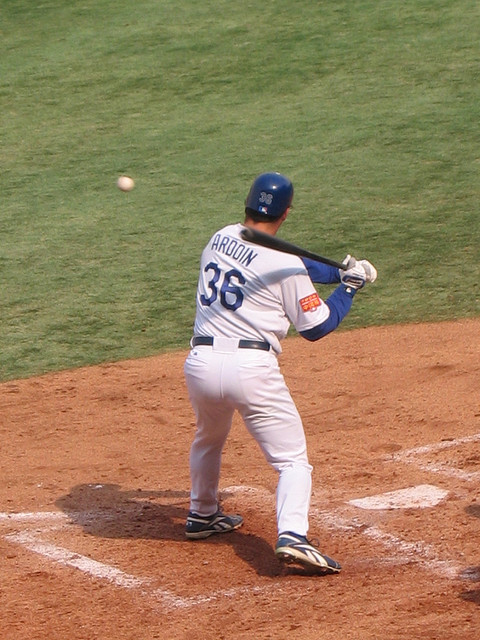<image>For what team does the player on the left play? It is unknown for what team the player on the left plays. It could be any team such as 'kansas city royals', 'cubs', 'mariners', 'boston', 'tigers', 'mets' or 'blue team'. For what team does the player on the left play? I don't know for which team the player on the left plays. It can be any team such as "Kansas City Royals", "Cubs", "Mariners", "Boston", "Tigers", "Mets", or "Blue team". 